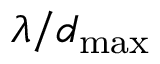<formula> <loc_0><loc_0><loc_500><loc_500>\lambda / d _ { \max }</formula> 